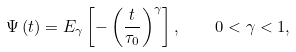<formula> <loc_0><loc_0><loc_500><loc_500>\Psi \left ( t \right ) = E _ { \gamma } \left [ - \left ( \frac { t } { \tau _ { 0 } } \right ) ^ { \gamma } \right ] , \quad 0 < \gamma < 1 ,</formula> 